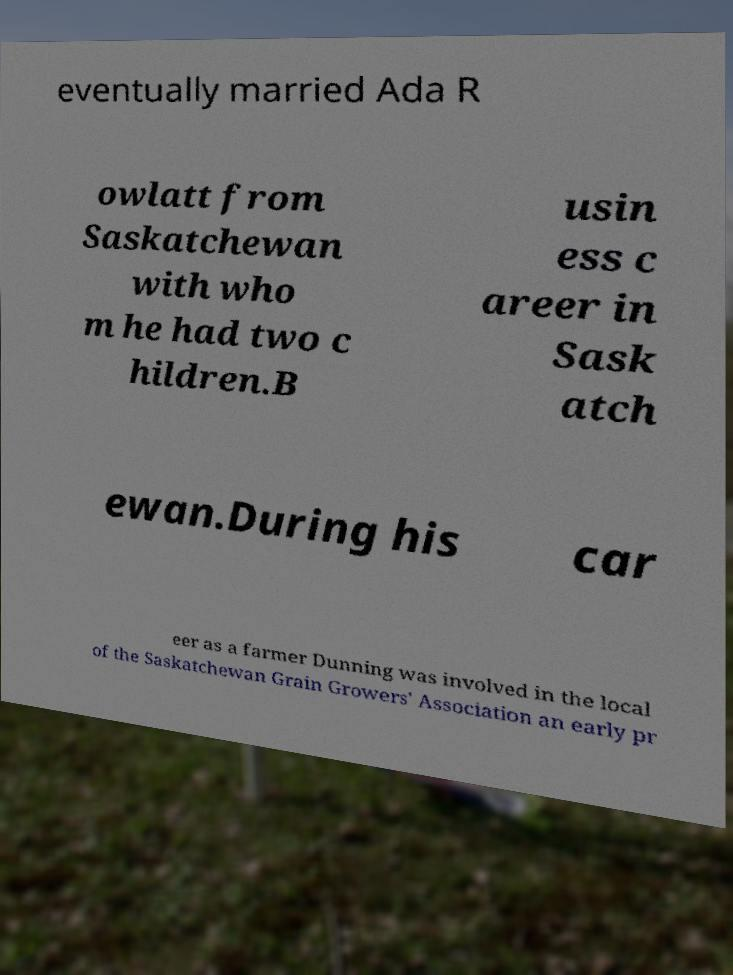Could you extract and type out the text from this image? eventually married Ada R owlatt from Saskatchewan with who m he had two c hildren.B usin ess c areer in Sask atch ewan.During his car eer as a farmer Dunning was involved in the local of the Saskatchewan Grain Growers' Association an early pr 